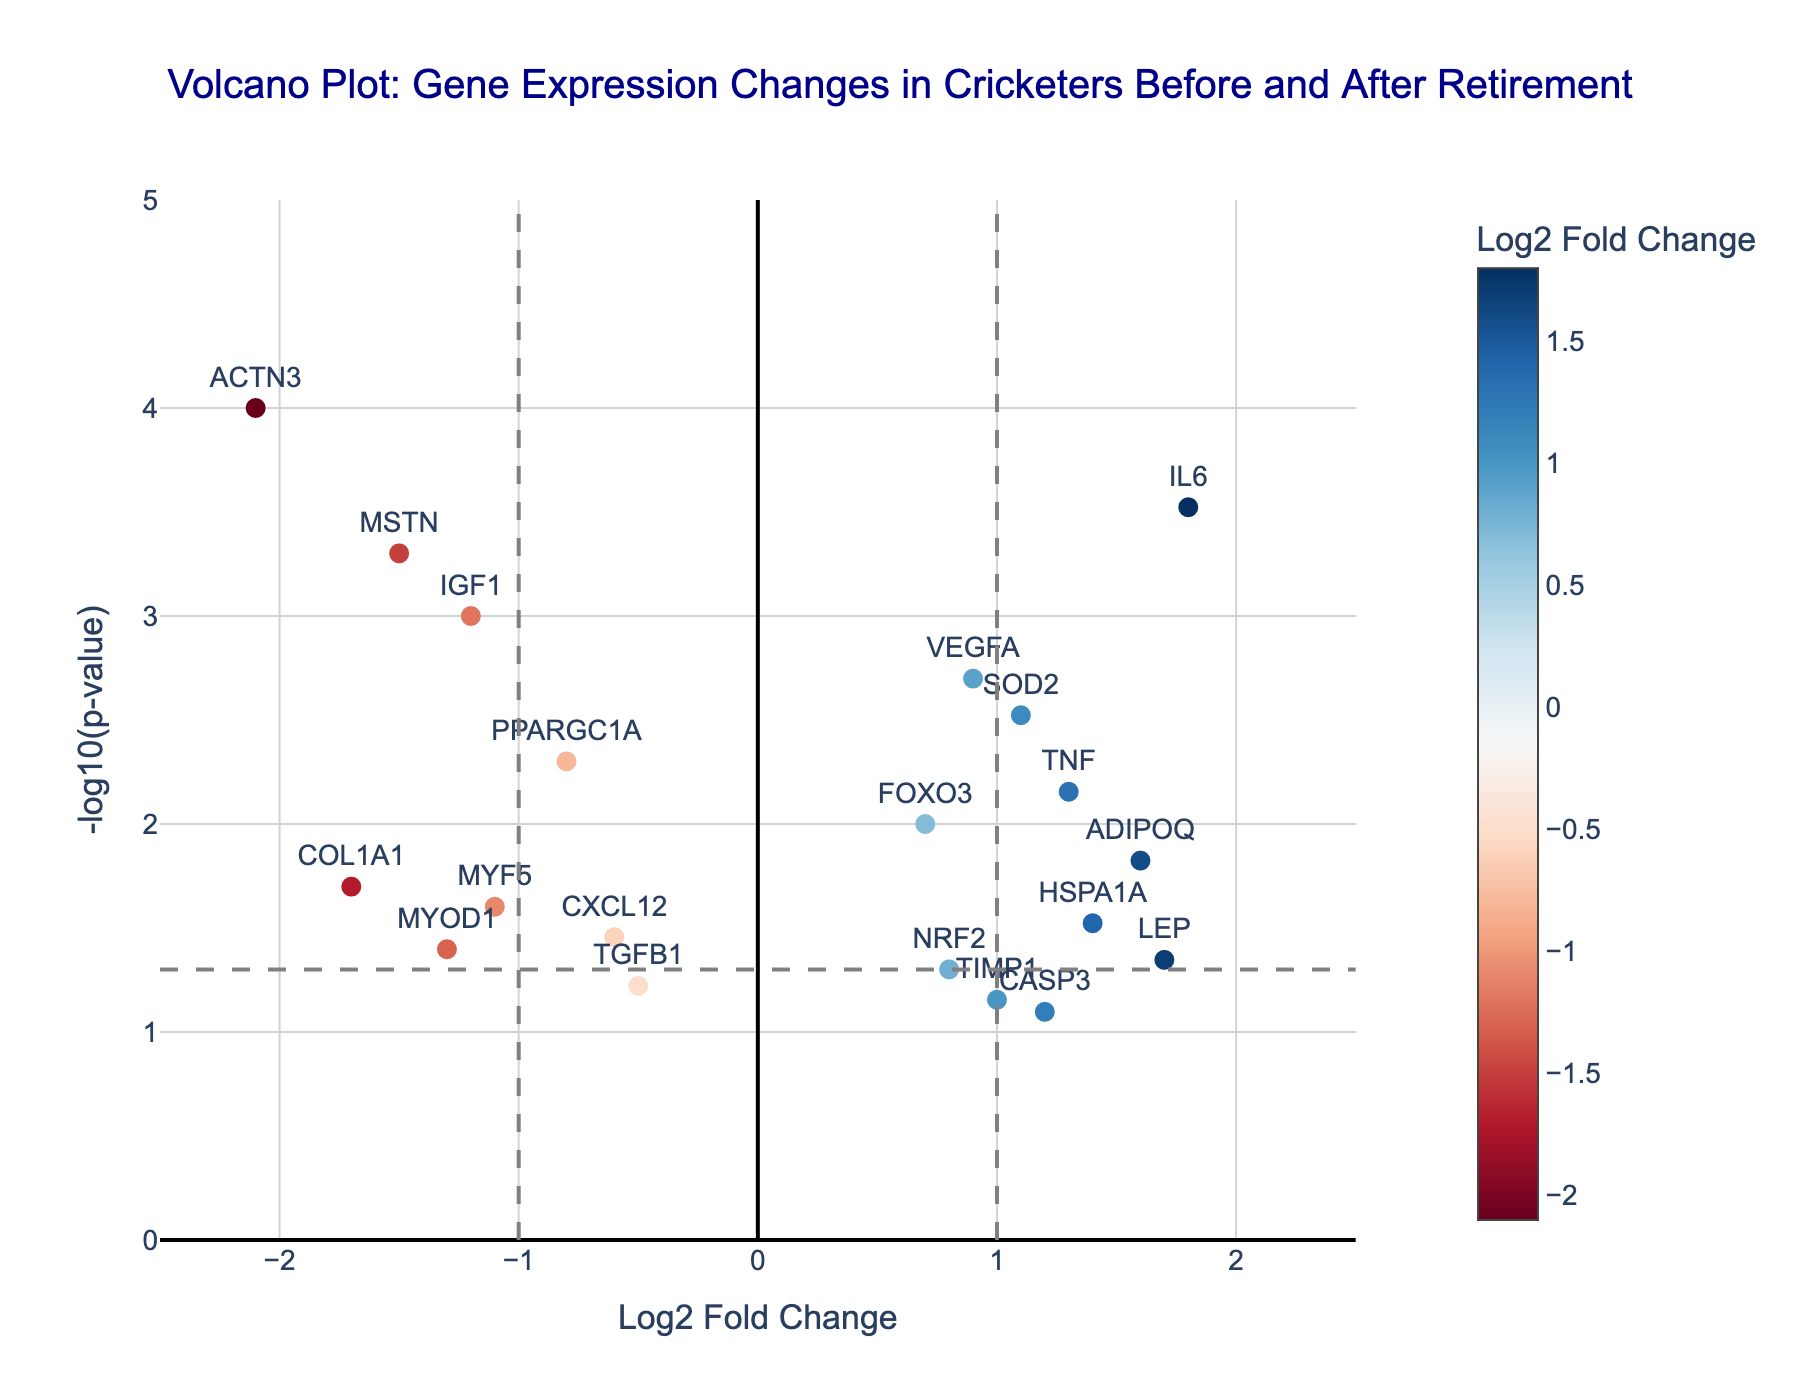What's the title of the plot? The title is usually located at the top of a plot. In this case, it should describe the general theme of the data being represented. Just look at the top of the plot for the information.
Answer: Volcano Plot: Gene Expression Changes in Cricketers Before and After Retirement Which genes are significantly up-regulated after retirement? To determine this, look for the genes that are positioned above the horizontal threshold line at -log10(p-value) = 1.3 and to the right of the vertical up-regulation threshold at Log2 Fold Change = 1.
Answer: IL6, TNF, ADIPOQ, LEP, HSPA1A, SOD2, CASP3 Which genes are significantly down-regulated after retirement? To determine this, look for the genes that are positioned above the horizontal threshold line at -log10(p-value) = 1.3 and to the left of the vertical down-regulation threshold at Log2 Fold Change = -1.
Answer: ACTN3, MSTN, COL1A1, IGF1, MYOD1 How many genes fall outside of the statistical significance threshold (p-value > 0.05)? Look for the genes that are positioned below the horizontal threshold line at -log10(p-value) = 1.3. Count these points.
Answer: Five genes Which gene shows the highest level of down-regulation? Look for the gene that is furthest to the left on the x-axis (most negative Log2 Fold Change) while still being above the horizontal significance threshold.
Answer: ACTN3 Which gene has the smallest p-value? The smallest p-value corresponds to the highest -log10(p-value). Look for the highest point on the y-axis.
Answer: ACTN3 How many genes show a log2 fold change between -1 and 1? Count the genes that fall between the two vertical lines set at Log2 Fold Change = -1 and 1, respectively.
Answer: Six genes What is the log2 fold change for gene LEP? Locate the gene LEP on the plot and read its Log2 Fold Change value.
Answer: 1.7 Are there any genes that are near the zero Log2 Fold Change line but still significant? Look for genes that are close to the vertical line at Log2 Fold Change = 0 but are above the horizontal significance threshold of -log10(p-value) = 1.3.
Answer: VEGFA Which genes have both Log2 Fold Change and -log10(p-value) greater than 1? Identify genes that are located to the right of the vertical line at Log2 Fold Change = 1 and above the horizontal line at -log10(p-value) = 1.
Answer: IL6, TNF, ADIPOQ 